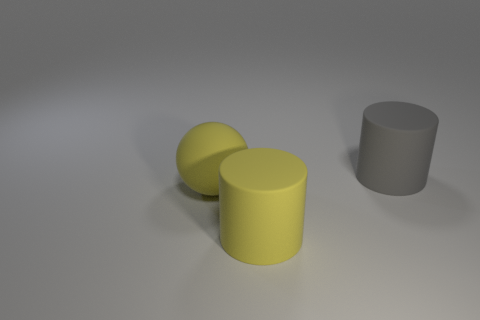Are there any balls on the right side of the big object that is to the left of the yellow cylinder?
Give a very brief answer. No. What is the big cylinder that is to the left of the gray cylinder made of?
Provide a succinct answer. Rubber. Are the large cylinder that is behind the large yellow ball and the big cylinder in front of the yellow sphere made of the same material?
Give a very brief answer. Yes. Are there the same number of large yellow cylinders to the left of the yellow cylinder and big things that are to the left of the large gray cylinder?
Provide a short and direct response. No. How many big spheres are made of the same material as the gray object?
Offer a terse response. 1. What is the size of the gray matte thing that is to the right of the large rubber cylinder that is in front of the gray rubber cylinder?
Ensure brevity in your answer.  Large. There is a big yellow matte thing that is behind the large yellow cylinder; is it the same shape as the thing that is right of the yellow cylinder?
Keep it short and to the point. No. Is the number of gray cylinders left of the yellow matte cylinder the same as the number of large yellow matte things?
Ensure brevity in your answer.  No. What is the color of the other large matte thing that is the same shape as the gray matte thing?
Your response must be concise. Yellow. Do the big cylinder that is to the left of the big gray rubber thing and the big yellow sphere have the same material?
Keep it short and to the point. Yes. 